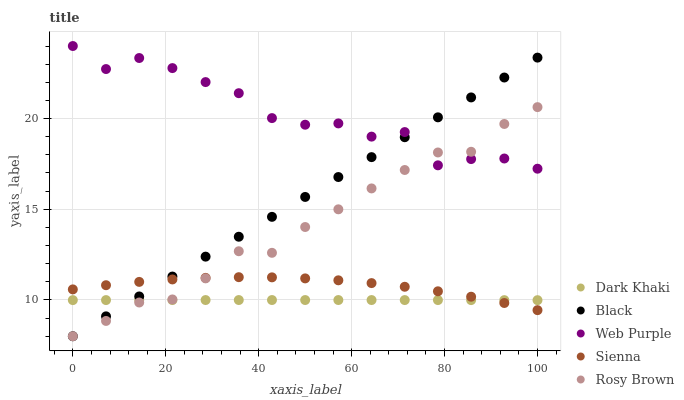Does Dark Khaki have the minimum area under the curve?
Answer yes or no. Yes. Does Web Purple have the maximum area under the curve?
Answer yes or no. Yes. Does Sienna have the minimum area under the curve?
Answer yes or no. No. Does Sienna have the maximum area under the curve?
Answer yes or no. No. Is Black the smoothest?
Answer yes or no. Yes. Is Web Purple the roughest?
Answer yes or no. Yes. Is Sienna the smoothest?
Answer yes or no. No. Is Sienna the roughest?
Answer yes or no. No. Does Rosy Brown have the lowest value?
Answer yes or no. Yes. Does Sienna have the lowest value?
Answer yes or no. No. Does Web Purple have the highest value?
Answer yes or no. Yes. Does Sienna have the highest value?
Answer yes or no. No. Is Dark Khaki less than Web Purple?
Answer yes or no. Yes. Is Web Purple greater than Sienna?
Answer yes or no. Yes. Does Dark Khaki intersect Rosy Brown?
Answer yes or no. Yes. Is Dark Khaki less than Rosy Brown?
Answer yes or no. No. Is Dark Khaki greater than Rosy Brown?
Answer yes or no. No. Does Dark Khaki intersect Web Purple?
Answer yes or no. No. 